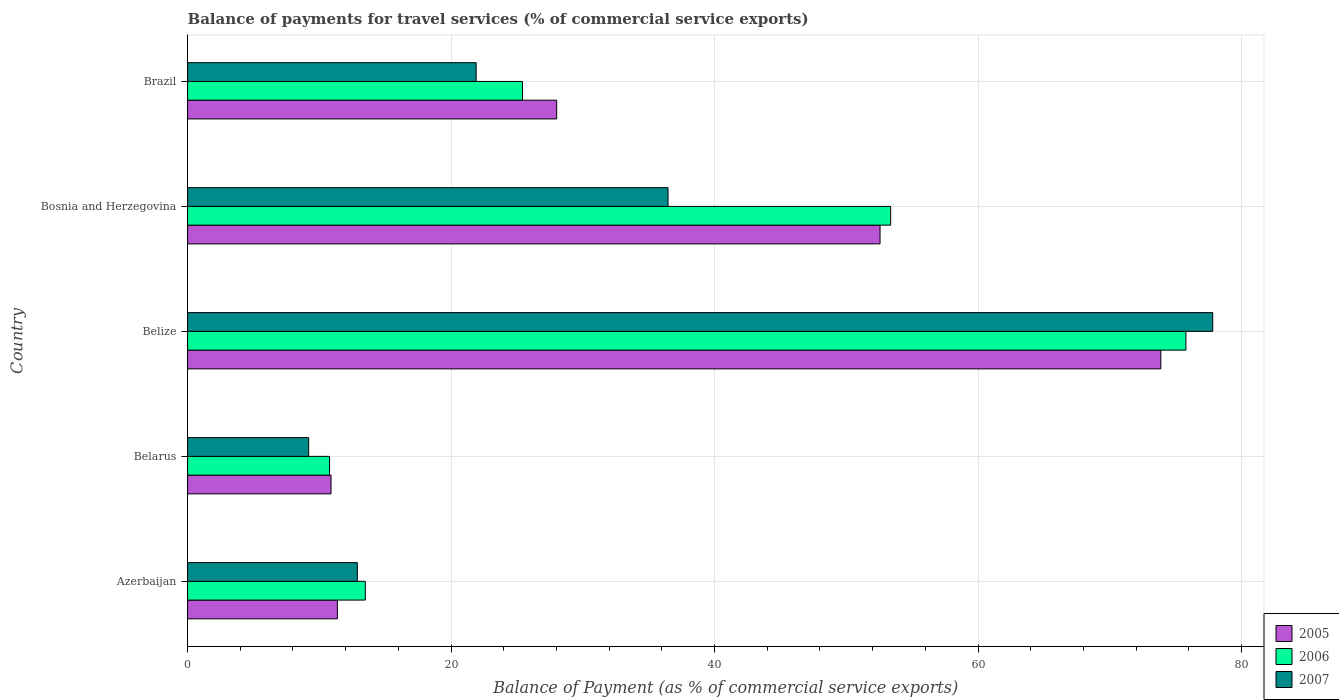How many different coloured bars are there?
Keep it short and to the point. 3. How many groups of bars are there?
Provide a short and direct response. 5. Are the number of bars per tick equal to the number of legend labels?
Your answer should be compact. Yes. Are the number of bars on each tick of the Y-axis equal?
Keep it short and to the point. Yes. How many bars are there on the 2nd tick from the top?
Make the answer very short. 3. How many bars are there on the 2nd tick from the bottom?
Your answer should be compact. 3. What is the label of the 2nd group of bars from the top?
Make the answer very short. Bosnia and Herzegovina. In how many cases, is the number of bars for a given country not equal to the number of legend labels?
Keep it short and to the point. 0. What is the balance of payments for travel services in 2007 in Belize?
Give a very brief answer. 77.81. Across all countries, what is the maximum balance of payments for travel services in 2006?
Your answer should be very brief. 75.78. Across all countries, what is the minimum balance of payments for travel services in 2007?
Offer a terse response. 9.19. In which country was the balance of payments for travel services in 2007 maximum?
Your answer should be compact. Belize. In which country was the balance of payments for travel services in 2006 minimum?
Your response must be concise. Belarus. What is the total balance of payments for travel services in 2007 in the graph?
Ensure brevity in your answer.  158.25. What is the difference between the balance of payments for travel services in 2007 in Azerbaijan and that in Belarus?
Make the answer very short. 3.7. What is the difference between the balance of payments for travel services in 2005 in Belize and the balance of payments for travel services in 2007 in Bosnia and Herzegovina?
Offer a terse response. 37.4. What is the average balance of payments for travel services in 2005 per country?
Your response must be concise. 35.34. What is the difference between the balance of payments for travel services in 2006 and balance of payments for travel services in 2007 in Belarus?
Make the answer very short. 1.59. In how many countries, is the balance of payments for travel services in 2005 greater than 20 %?
Provide a short and direct response. 3. What is the ratio of the balance of payments for travel services in 2007 in Belarus to that in Belize?
Your response must be concise. 0.12. What is the difference between the highest and the second highest balance of payments for travel services in 2005?
Give a very brief answer. 21.31. What is the difference between the highest and the lowest balance of payments for travel services in 2007?
Your answer should be compact. 68.62. What does the 1st bar from the top in Belize represents?
Give a very brief answer. 2007. What does the 3rd bar from the bottom in Belarus represents?
Offer a very short reply. 2007. Is it the case that in every country, the sum of the balance of payments for travel services in 2006 and balance of payments for travel services in 2007 is greater than the balance of payments for travel services in 2005?
Provide a succinct answer. Yes. Are all the bars in the graph horizontal?
Ensure brevity in your answer.  Yes. How many countries are there in the graph?
Ensure brevity in your answer.  5. What is the difference between two consecutive major ticks on the X-axis?
Provide a succinct answer. 20. Are the values on the major ticks of X-axis written in scientific E-notation?
Give a very brief answer. No. Does the graph contain any zero values?
Your response must be concise. No. Where does the legend appear in the graph?
Your response must be concise. Bottom right. How many legend labels are there?
Provide a succinct answer. 3. How are the legend labels stacked?
Your answer should be very brief. Vertical. What is the title of the graph?
Your response must be concise. Balance of payments for travel services (% of commercial service exports). Does "2003" appear as one of the legend labels in the graph?
Offer a terse response. No. What is the label or title of the X-axis?
Provide a succinct answer. Balance of Payment (as % of commercial service exports). What is the label or title of the Y-axis?
Your answer should be compact. Country. What is the Balance of Payment (as % of commercial service exports) in 2005 in Azerbaijan?
Your answer should be compact. 11.37. What is the Balance of Payment (as % of commercial service exports) in 2006 in Azerbaijan?
Offer a very short reply. 13.49. What is the Balance of Payment (as % of commercial service exports) of 2007 in Azerbaijan?
Ensure brevity in your answer.  12.88. What is the Balance of Payment (as % of commercial service exports) in 2005 in Belarus?
Keep it short and to the point. 10.89. What is the Balance of Payment (as % of commercial service exports) of 2006 in Belarus?
Offer a very short reply. 10.77. What is the Balance of Payment (as % of commercial service exports) of 2007 in Belarus?
Offer a very short reply. 9.19. What is the Balance of Payment (as % of commercial service exports) in 2005 in Belize?
Offer a terse response. 73.87. What is the Balance of Payment (as % of commercial service exports) of 2006 in Belize?
Provide a short and direct response. 75.78. What is the Balance of Payment (as % of commercial service exports) of 2007 in Belize?
Ensure brevity in your answer.  77.81. What is the Balance of Payment (as % of commercial service exports) of 2005 in Bosnia and Herzegovina?
Your answer should be compact. 52.56. What is the Balance of Payment (as % of commercial service exports) in 2006 in Bosnia and Herzegovina?
Offer a terse response. 53.36. What is the Balance of Payment (as % of commercial service exports) of 2007 in Bosnia and Herzegovina?
Keep it short and to the point. 36.47. What is the Balance of Payment (as % of commercial service exports) in 2005 in Brazil?
Your response must be concise. 28.01. What is the Balance of Payment (as % of commercial service exports) in 2006 in Brazil?
Offer a terse response. 25.42. What is the Balance of Payment (as % of commercial service exports) in 2007 in Brazil?
Make the answer very short. 21.9. Across all countries, what is the maximum Balance of Payment (as % of commercial service exports) in 2005?
Provide a succinct answer. 73.87. Across all countries, what is the maximum Balance of Payment (as % of commercial service exports) of 2006?
Make the answer very short. 75.78. Across all countries, what is the maximum Balance of Payment (as % of commercial service exports) of 2007?
Offer a very short reply. 77.81. Across all countries, what is the minimum Balance of Payment (as % of commercial service exports) in 2005?
Your response must be concise. 10.89. Across all countries, what is the minimum Balance of Payment (as % of commercial service exports) in 2006?
Offer a terse response. 10.77. Across all countries, what is the minimum Balance of Payment (as % of commercial service exports) in 2007?
Your answer should be compact. 9.19. What is the total Balance of Payment (as % of commercial service exports) of 2005 in the graph?
Offer a very short reply. 176.7. What is the total Balance of Payment (as % of commercial service exports) in 2006 in the graph?
Offer a terse response. 178.82. What is the total Balance of Payment (as % of commercial service exports) of 2007 in the graph?
Your answer should be very brief. 158.25. What is the difference between the Balance of Payment (as % of commercial service exports) of 2005 in Azerbaijan and that in Belarus?
Your response must be concise. 0.48. What is the difference between the Balance of Payment (as % of commercial service exports) in 2006 in Azerbaijan and that in Belarus?
Your response must be concise. 2.71. What is the difference between the Balance of Payment (as % of commercial service exports) in 2007 in Azerbaijan and that in Belarus?
Make the answer very short. 3.69. What is the difference between the Balance of Payment (as % of commercial service exports) in 2005 in Azerbaijan and that in Belize?
Make the answer very short. -62.5. What is the difference between the Balance of Payment (as % of commercial service exports) in 2006 in Azerbaijan and that in Belize?
Give a very brief answer. -62.29. What is the difference between the Balance of Payment (as % of commercial service exports) of 2007 in Azerbaijan and that in Belize?
Offer a very short reply. -64.93. What is the difference between the Balance of Payment (as % of commercial service exports) in 2005 in Azerbaijan and that in Bosnia and Herzegovina?
Offer a terse response. -41.19. What is the difference between the Balance of Payment (as % of commercial service exports) of 2006 in Azerbaijan and that in Bosnia and Herzegovina?
Ensure brevity in your answer.  -39.87. What is the difference between the Balance of Payment (as % of commercial service exports) in 2007 in Azerbaijan and that in Bosnia and Herzegovina?
Your answer should be compact. -23.58. What is the difference between the Balance of Payment (as % of commercial service exports) of 2005 in Azerbaijan and that in Brazil?
Your response must be concise. -16.64. What is the difference between the Balance of Payment (as % of commercial service exports) in 2006 in Azerbaijan and that in Brazil?
Your response must be concise. -11.93. What is the difference between the Balance of Payment (as % of commercial service exports) in 2007 in Azerbaijan and that in Brazil?
Your answer should be very brief. -9.02. What is the difference between the Balance of Payment (as % of commercial service exports) of 2005 in Belarus and that in Belize?
Provide a succinct answer. -62.98. What is the difference between the Balance of Payment (as % of commercial service exports) in 2006 in Belarus and that in Belize?
Your answer should be compact. -65. What is the difference between the Balance of Payment (as % of commercial service exports) in 2007 in Belarus and that in Belize?
Provide a succinct answer. -68.62. What is the difference between the Balance of Payment (as % of commercial service exports) in 2005 in Belarus and that in Bosnia and Herzegovina?
Keep it short and to the point. -41.67. What is the difference between the Balance of Payment (as % of commercial service exports) of 2006 in Belarus and that in Bosnia and Herzegovina?
Ensure brevity in your answer.  -42.59. What is the difference between the Balance of Payment (as % of commercial service exports) of 2007 in Belarus and that in Bosnia and Herzegovina?
Keep it short and to the point. -27.28. What is the difference between the Balance of Payment (as % of commercial service exports) of 2005 in Belarus and that in Brazil?
Make the answer very short. -17.13. What is the difference between the Balance of Payment (as % of commercial service exports) of 2006 in Belarus and that in Brazil?
Keep it short and to the point. -14.65. What is the difference between the Balance of Payment (as % of commercial service exports) in 2007 in Belarus and that in Brazil?
Your answer should be very brief. -12.71. What is the difference between the Balance of Payment (as % of commercial service exports) in 2005 in Belize and that in Bosnia and Herzegovina?
Make the answer very short. 21.31. What is the difference between the Balance of Payment (as % of commercial service exports) in 2006 in Belize and that in Bosnia and Herzegovina?
Provide a succinct answer. 22.41. What is the difference between the Balance of Payment (as % of commercial service exports) in 2007 in Belize and that in Bosnia and Herzegovina?
Ensure brevity in your answer.  41.34. What is the difference between the Balance of Payment (as % of commercial service exports) in 2005 in Belize and that in Brazil?
Your answer should be very brief. 45.86. What is the difference between the Balance of Payment (as % of commercial service exports) of 2006 in Belize and that in Brazil?
Keep it short and to the point. 50.36. What is the difference between the Balance of Payment (as % of commercial service exports) of 2007 in Belize and that in Brazil?
Your response must be concise. 55.91. What is the difference between the Balance of Payment (as % of commercial service exports) in 2005 in Bosnia and Herzegovina and that in Brazil?
Your response must be concise. 24.55. What is the difference between the Balance of Payment (as % of commercial service exports) in 2006 in Bosnia and Herzegovina and that in Brazil?
Your answer should be very brief. 27.94. What is the difference between the Balance of Payment (as % of commercial service exports) in 2007 in Bosnia and Herzegovina and that in Brazil?
Offer a very short reply. 14.57. What is the difference between the Balance of Payment (as % of commercial service exports) in 2005 in Azerbaijan and the Balance of Payment (as % of commercial service exports) in 2006 in Belarus?
Provide a succinct answer. 0.59. What is the difference between the Balance of Payment (as % of commercial service exports) in 2005 in Azerbaijan and the Balance of Payment (as % of commercial service exports) in 2007 in Belarus?
Make the answer very short. 2.18. What is the difference between the Balance of Payment (as % of commercial service exports) of 2006 in Azerbaijan and the Balance of Payment (as % of commercial service exports) of 2007 in Belarus?
Provide a succinct answer. 4.3. What is the difference between the Balance of Payment (as % of commercial service exports) in 2005 in Azerbaijan and the Balance of Payment (as % of commercial service exports) in 2006 in Belize?
Ensure brevity in your answer.  -64.41. What is the difference between the Balance of Payment (as % of commercial service exports) of 2005 in Azerbaijan and the Balance of Payment (as % of commercial service exports) of 2007 in Belize?
Ensure brevity in your answer.  -66.44. What is the difference between the Balance of Payment (as % of commercial service exports) in 2006 in Azerbaijan and the Balance of Payment (as % of commercial service exports) in 2007 in Belize?
Keep it short and to the point. -64.32. What is the difference between the Balance of Payment (as % of commercial service exports) of 2005 in Azerbaijan and the Balance of Payment (as % of commercial service exports) of 2006 in Bosnia and Herzegovina?
Your answer should be very brief. -41.99. What is the difference between the Balance of Payment (as % of commercial service exports) in 2005 in Azerbaijan and the Balance of Payment (as % of commercial service exports) in 2007 in Bosnia and Herzegovina?
Make the answer very short. -25.1. What is the difference between the Balance of Payment (as % of commercial service exports) of 2006 in Azerbaijan and the Balance of Payment (as % of commercial service exports) of 2007 in Bosnia and Herzegovina?
Make the answer very short. -22.98. What is the difference between the Balance of Payment (as % of commercial service exports) of 2005 in Azerbaijan and the Balance of Payment (as % of commercial service exports) of 2006 in Brazil?
Your response must be concise. -14.05. What is the difference between the Balance of Payment (as % of commercial service exports) of 2005 in Azerbaijan and the Balance of Payment (as % of commercial service exports) of 2007 in Brazil?
Keep it short and to the point. -10.53. What is the difference between the Balance of Payment (as % of commercial service exports) of 2006 in Azerbaijan and the Balance of Payment (as % of commercial service exports) of 2007 in Brazil?
Provide a succinct answer. -8.41. What is the difference between the Balance of Payment (as % of commercial service exports) of 2005 in Belarus and the Balance of Payment (as % of commercial service exports) of 2006 in Belize?
Provide a succinct answer. -64.89. What is the difference between the Balance of Payment (as % of commercial service exports) of 2005 in Belarus and the Balance of Payment (as % of commercial service exports) of 2007 in Belize?
Offer a very short reply. -66.93. What is the difference between the Balance of Payment (as % of commercial service exports) of 2006 in Belarus and the Balance of Payment (as % of commercial service exports) of 2007 in Belize?
Your response must be concise. -67.04. What is the difference between the Balance of Payment (as % of commercial service exports) of 2005 in Belarus and the Balance of Payment (as % of commercial service exports) of 2006 in Bosnia and Herzegovina?
Offer a very short reply. -42.48. What is the difference between the Balance of Payment (as % of commercial service exports) in 2005 in Belarus and the Balance of Payment (as % of commercial service exports) in 2007 in Bosnia and Herzegovina?
Ensure brevity in your answer.  -25.58. What is the difference between the Balance of Payment (as % of commercial service exports) of 2006 in Belarus and the Balance of Payment (as % of commercial service exports) of 2007 in Bosnia and Herzegovina?
Your response must be concise. -25.69. What is the difference between the Balance of Payment (as % of commercial service exports) in 2005 in Belarus and the Balance of Payment (as % of commercial service exports) in 2006 in Brazil?
Offer a very short reply. -14.53. What is the difference between the Balance of Payment (as % of commercial service exports) of 2005 in Belarus and the Balance of Payment (as % of commercial service exports) of 2007 in Brazil?
Provide a succinct answer. -11.01. What is the difference between the Balance of Payment (as % of commercial service exports) in 2006 in Belarus and the Balance of Payment (as % of commercial service exports) in 2007 in Brazil?
Offer a terse response. -11.13. What is the difference between the Balance of Payment (as % of commercial service exports) in 2005 in Belize and the Balance of Payment (as % of commercial service exports) in 2006 in Bosnia and Herzegovina?
Offer a terse response. 20.51. What is the difference between the Balance of Payment (as % of commercial service exports) in 2005 in Belize and the Balance of Payment (as % of commercial service exports) in 2007 in Bosnia and Herzegovina?
Your answer should be compact. 37.4. What is the difference between the Balance of Payment (as % of commercial service exports) in 2006 in Belize and the Balance of Payment (as % of commercial service exports) in 2007 in Bosnia and Herzegovina?
Your response must be concise. 39.31. What is the difference between the Balance of Payment (as % of commercial service exports) of 2005 in Belize and the Balance of Payment (as % of commercial service exports) of 2006 in Brazil?
Offer a terse response. 48.45. What is the difference between the Balance of Payment (as % of commercial service exports) of 2005 in Belize and the Balance of Payment (as % of commercial service exports) of 2007 in Brazil?
Keep it short and to the point. 51.97. What is the difference between the Balance of Payment (as % of commercial service exports) of 2006 in Belize and the Balance of Payment (as % of commercial service exports) of 2007 in Brazil?
Your answer should be very brief. 53.88. What is the difference between the Balance of Payment (as % of commercial service exports) in 2005 in Bosnia and Herzegovina and the Balance of Payment (as % of commercial service exports) in 2006 in Brazil?
Your answer should be very brief. 27.14. What is the difference between the Balance of Payment (as % of commercial service exports) of 2005 in Bosnia and Herzegovina and the Balance of Payment (as % of commercial service exports) of 2007 in Brazil?
Provide a short and direct response. 30.66. What is the difference between the Balance of Payment (as % of commercial service exports) of 2006 in Bosnia and Herzegovina and the Balance of Payment (as % of commercial service exports) of 2007 in Brazil?
Provide a short and direct response. 31.46. What is the average Balance of Payment (as % of commercial service exports) of 2005 per country?
Your answer should be very brief. 35.34. What is the average Balance of Payment (as % of commercial service exports) in 2006 per country?
Offer a very short reply. 35.76. What is the average Balance of Payment (as % of commercial service exports) of 2007 per country?
Ensure brevity in your answer.  31.65. What is the difference between the Balance of Payment (as % of commercial service exports) of 2005 and Balance of Payment (as % of commercial service exports) of 2006 in Azerbaijan?
Keep it short and to the point. -2.12. What is the difference between the Balance of Payment (as % of commercial service exports) in 2005 and Balance of Payment (as % of commercial service exports) in 2007 in Azerbaijan?
Make the answer very short. -1.51. What is the difference between the Balance of Payment (as % of commercial service exports) of 2006 and Balance of Payment (as % of commercial service exports) of 2007 in Azerbaijan?
Offer a very short reply. 0.61. What is the difference between the Balance of Payment (as % of commercial service exports) in 2005 and Balance of Payment (as % of commercial service exports) in 2006 in Belarus?
Your response must be concise. 0.11. What is the difference between the Balance of Payment (as % of commercial service exports) in 2005 and Balance of Payment (as % of commercial service exports) in 2007 in Belarus?
Provide a succinct answer. 1.7. What is the difference between the Balance of Payment (as % of commercial service exports) in 2006 and Balance of Payment (as % of commercial service exports) in 2007 in Belarus?
Give a very brief answer. 1.59. What is the difference between the Balance of Payment (as % of commercial service exports) in 2005 and Balance of Payment (as % of commercial service exports) in 2006 in Belize?
Your answer should be very brief. -1.91. What is the difference between the Balance of Payment (as % of commercial service exports) in 2005 and Balance of Payment (as % of commercial service exports) in 2007 in Belize?
Your answer should be compact. -3.94. What is the difference between the Balance of Payment (as % of commercial service exports) in 2006 and Balance of Payment (as % of commercial service exports) in 2007 in Belize?
Give a very brief answer. -2.04. What is the difference between the Balance of Payment (as % of commercial service exports) in 2005 and Balance of Payment (as % of commercial service exports) in 2006 in Bosnia and Herzegovina?
Offer a terse response. -0.8. What is the difference between the Balance of Payment (as % of commercial service exports) of 2005 and Balance of Payment (as % of commercial service exports) of 2007 in Bosnia and Herzegovina?
Offer a very short reply. 16.09. What is the difference between the Balance of Payment (as % of commercial service exports) of 2006 and Balance of Payment (as % of commercial service exports) of 2007 in Bosnia and Herzegovina?
Your answer should be very brief. 16.9. What is the difference between the Balance of Payment (as % of commercial service exports) in 2005 and Balance of Payment (as % of commercial service exports) in 2006 in Brazil?
Keep it short and to the point. 2.59. What is the difference between the Balance of Payment (as % of commercial service exports) of 2005 and Balance of Payment (as % of commercial service exports) of 2007 in Brazil?
Your response must be concise. 6.11. What is the difference between the Balance of Payment (as % of commercial service exports) in 2006 and Balance of Payment (as % of commercial service exports) in 2007 in Brazil?
Offer a terse response. 3.52. What is the ratio of the Balance of Payment (as % of commercial service exports) in 2005 in Azerbaijan to that in Belarus?
Provide a short and direct response. 1.04. What is the ratio of the Balance of Payment (as % of commercial service exports) of 2006 in Azerbaijan to that in Belarus?
Give a very brief answer. 1.25. What is the ratio of the Balance of Payment (as % of commercial service exports) of 2007 in Azerbaijan to that in Belarus?
Provide a short and direct response. 1.4. What is the ratio of the Balance of Payment (as % of commercial service exports) in 2005 in Azerbaijan to that in Belize?
Keep it short and to the point. 0.15. What is the ratio of the Balance of Payment (as % of commercial service exports) of 2006 in Azerbaijan to that in Belize?
Make the answer very short. 0.18. What is the ratio of the Balance of Payment (as % of commercial service exports) of 2007 in Azerbaijan to that in Belize?
Your response must be concise. 0.17. What is the ratio of the Balance of Payment (as % of commercial service exports) in 2005 in Azerbaijan to that in Bosnia and Herzegovina?
Your response must be concise. 0.22. What is the ratio of the Balance of Payment (as % of commercial service exports) of 2006 in Azerbaijan to that in Bosnia and Herzegovina?
Provide a short and direct response. 0.25. What is the ratio of the Balance of Payment (as % of commercial service exports) of 2007 in Azerbaijan to that in Bosnia and Herzegovina?
Keep it short and to the point. 0.35. What is the ratio of the Balance of Payment (as % of commercial service exports) in 2005 in Azerbaijan to that in Brazil?
Provide a succinct answer. 0.41. What is the ratio of the Balance of Payment (as % of commercial service exports) in 2006 in Azerbaijan to that in Brazil?
Make the answer very short. 0.53. What is the ratio of the Balance of Payment (as % of commercial service exports) in 2007 in Azerbaijan to that in Brazil?
Your answer should be compact. 0.59. What is the ratio of the Balance of Payment (as % of commercial service exports) of 2005 in Belarus to that in Belize?
Offer a very short reply. 0.15. What is the ratio of the Balance of Payment (as % of commercial service exports) of 2006 in Belarus to that in Belize?
Make the answer very short. 0.14. What is the ratio of the Balance of Payment (as % of commercial service exports) of 2007 in Belarus to that in Belize?
Give a very brief answer. 0.12. What is the ratio of the Balance of Payment (as % of commercial service exports) in 2005 in Belarus to that in Bosnia and Herzegovina?
Make the answer very short. 0.21. What is the ratio of the Balance of Payment (as % of commercial service exports) in 2006 in Belarus to that in Bosnia and Herzegovina?
Provide a short and direct response. 0.2. What is the ratio of the Balance of Payment (as % of commercial service exports) in 2007 in Belarus to that in Bosnia and Herzegovina?
Your answer should be compact. 0.25. What is the ratio of the Balance of Payment (as % of commercial service exports) of 2005 in Belarus to that in Brazil?
Make the answer very short. 0.39. What is the ratio of the Balance of Payment (as % of commercial service exports) in 2006 in Belarus to that in Brazil?
Your answer should be compact. 0.42. What is the ratio of the Balance of Payment (as % of commercial service exports) of 2007 in Belarus to that in Brazil?
Your answer should be very brief. 0.42. What is the ratio of the Balance of Payment (as % of commercial service exports) of 2005 in Belize to that in Bosnia and Herzegovina?
Your response must be concise. 1.41. What is the ratio of the Balance of Payment (as % of commercial service exports) in 2006 in Belize to that in Bosnia and Herzegovina?
Offer a terse response. 1.42. What is the ratio of the Balance of Payment (as % of commercial service exports) in 2007 in Belize to that in Bosnia and Herzegovina?
Make the answer very short. 2.13. What is the ratio of the Balance of Payment (as % of commercial service exports) of 2005 in Belize to that in Brazil?
Your response must be concise. 2.64. What is the ratio of the Balance of Payment (as % of commercial service exports) in 2006 in Belize to that in Brazil?
Your answer should be very brief. 2.98. What is the ratio of the Balance of Payment (as % of commercial service exports) of 2007 in Belize to that in Brazil?
Your response must be concise. 3.55. What is the ratio of the Balance of Payment (as % of commercial service exports) of 2005 in Bosnia and Herzegovina to that in Brazil?
Offer a terse response. 1.88. What is the ratio of the Balance of Payment (as % of commercial service exports) in 2006 in Bosnia and Herzegovina to that in Brazil?
Offer a very short reply. 2.1. What is the ratio of the Balance of Payment (as % of commercial service exports) in 2007 in Bosnia and Herzegovina to that in Brazil?
Your answer should be compact. 1.67. What is the difference between the highest and the second highest Balance of Payment (as % of commercial service exports) of 2005?
Make the answer very short. 21.31. What is the difference between the highest and the second highest Balance of Payment (as % of commercial service exports) of 2006?
Your response must be concise. 22.41. What is the difference between the highest and the second highest Balance of Payment (as % of commercial service exports) in 2007?
Provide a short and direct response. 41.34. What is the difference between the highest and the lowest Balance of Payment (as % of commercial service exports) of 2005?
Provide a short and direct response. 62.98. What is the difference between the highest and the lowest Balance of Payment (as % of commercial service exports) in 2006?
Your answer should be compact. 65. What is the difference between the highest and the lowest Balance of Payment (as % of commercial service exports) in 2007?
Make the answer very short. 68.62. 